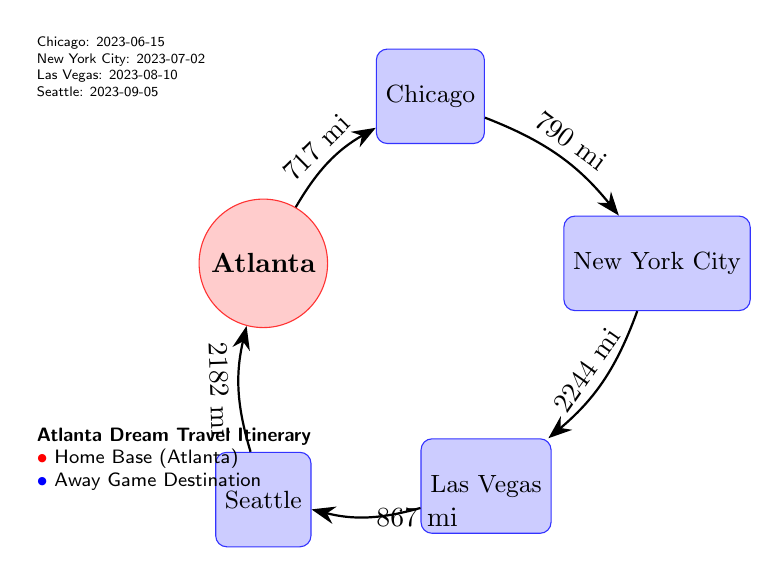What is the home base of the Atlanta Dream? The home base is clearly represented as a red circle labeled "Atlanta" in the diagram, indicating the starting point of their travel itinerary.
Answer: Atlanta How many away game destinations are listed in the diagram? The diagram includes four destination nodes: Chicago, New York City, Las Vegas, and Seattle. Therefore, counting these nodes gives us the total number of away destinations.
Answer: 4 What is the distance from Atlanta to Chicago? The arrow connecting Atlanta to Chicago includes a label stating "717 mi," indicating the distance between these two points.
Answer: 717 mi What is the last away game destination listed in the itinerary? The last destination is shown as "Seattle," listed at the end of the textual information next to the diagram, following the other cities.
Answer: Seattle How far is it from Las Vegas to Seattle? The arrow connecting Las Vegas to Seattle displays a distance labeled "867 mi," directly providing the distance for this segment of travel.
Answer: 867 mi What is the distance covered from Seattle back to Atlanta? The diagram shows the arrow from Seattle to Atlanta labeled "2182 mi." This represents the total distance for this segment of the trip.
Answer: 2182 mi What is the first away game date in the itinerary? The first game listed under the destinations is "Chicago," with the date specified as "2023-06-15."
Answer: 2023-06-15 What is the total distance from Chicago to New York City? The connection between Chicago and New York City indicates a distance of "790 mi" on the diagram, which directly provides the distance for this route.
Answer: 790 mi What shape represents the away game destinations in the diagram? The away game destinations are represented by rectangles in the diagram, distinguished by their blue color and specific labeling.
Answer: Rectangle 